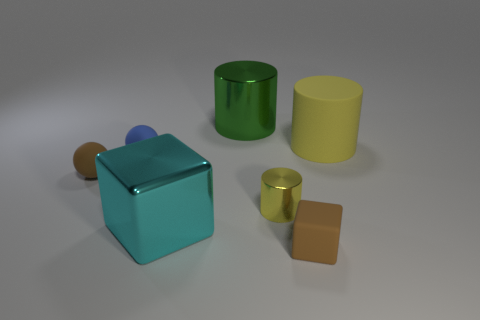What size is the object that is the same color as the big matte cylinder?
Your answer should be very brief. Small. There is a big cyan metallic thing; are there any small brown rubber blocks behind it?
Provide a short and direct response. No. The tiny thing that is in front of the cyan shiny cube is what color?
Make the answer very short. Brown. The cylinder in front of the yellow cylinder right of the brown cube is made of what material?
Make the answer very short. Metal. Is the number of large green cylinders that are right of the small brown matte cube less than the number of green cylinders left of the cyan thing?
Offer a terse response. No. What number of cyan objects are either large cylinders or cylinders?
Keep it short and to the point. 0. Are there the same number of brown matte spheres that are behind the green thing and cylinders?
Provide a succinct answer. No. What number of objects are cyan metal cubes or tiny things in front of the blue object?
Keep it short and to the point. 4. Do the big shiny cylinder and the tiny metal thing have the same color?
Make the answer very short. No. Is there a gray ball made of the same material as the large green thing?
Your answer should be compact. No. 